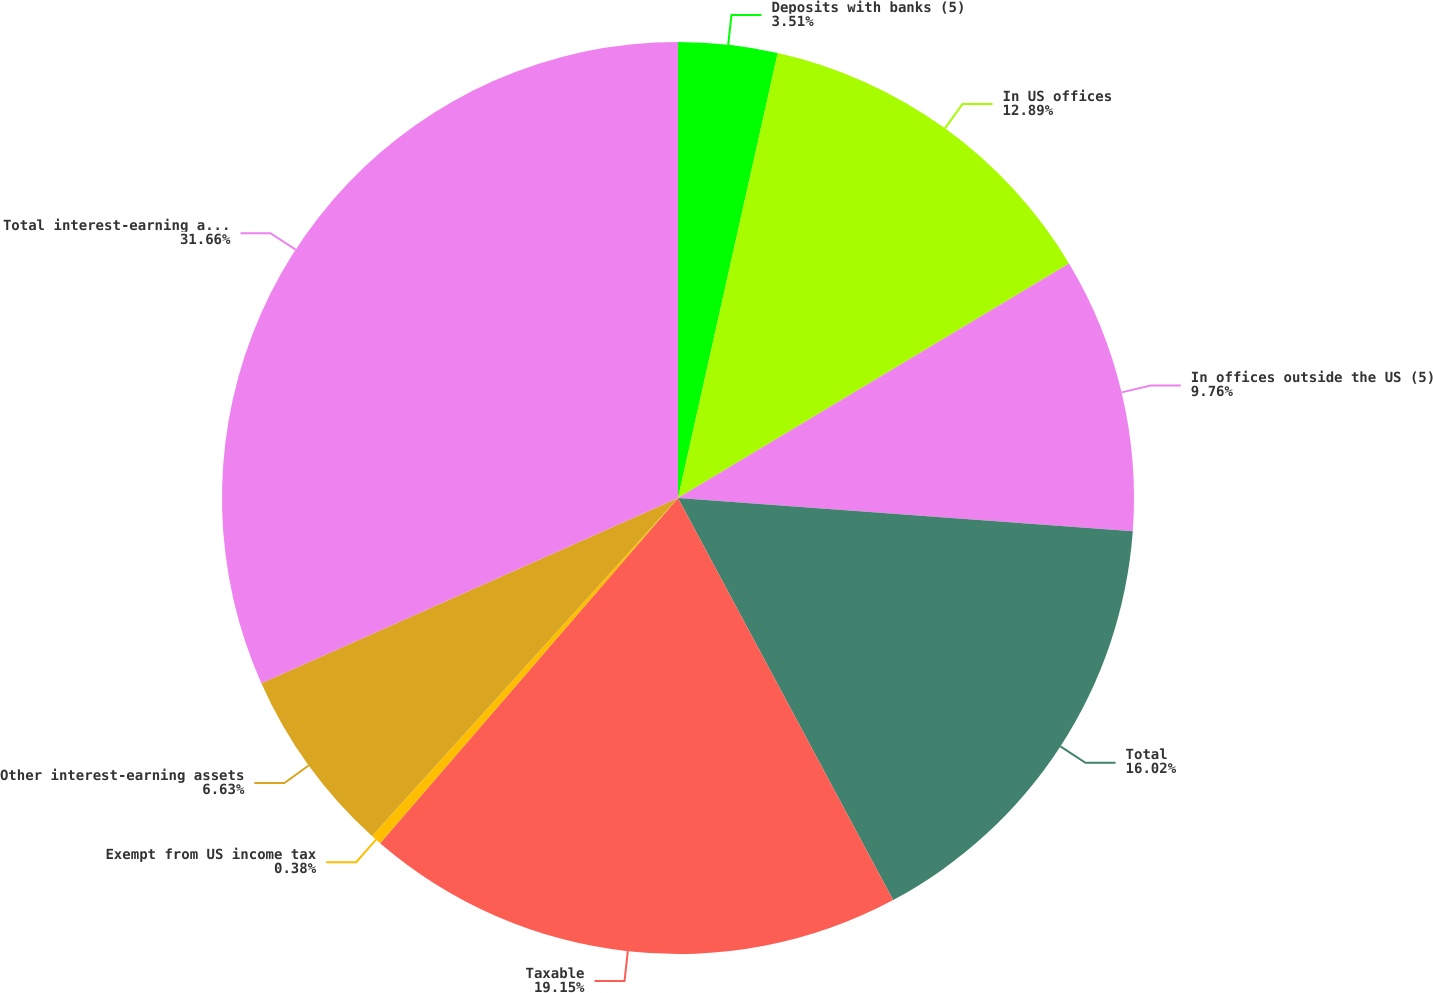Convert chart. <chart><loc_0><loc_0><loc_500><loc_500><pie_chart><fcel>Deposits with banks (5)<fcel>In US offices<fcel>In offices outside the US (5)<fcel>Total<fcel>Taxable<fcel>Exempt from US income tax<fcel>Other interest-earning assets<fcel>Total interest-earning assets<nl><fcel>3.51%<fcel>12.89%<fcel>9.76%<fcel>16.02%<fcel>19.15%<fcel>0.38%<fcel>6.63%<fcel>31.66%<nl></chart> 